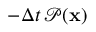Convert formula to latex. <formula><loc_0><loc_0><loc_500><loc_500>- \Delta t \, \mathcal { P } ( x )</formula> 